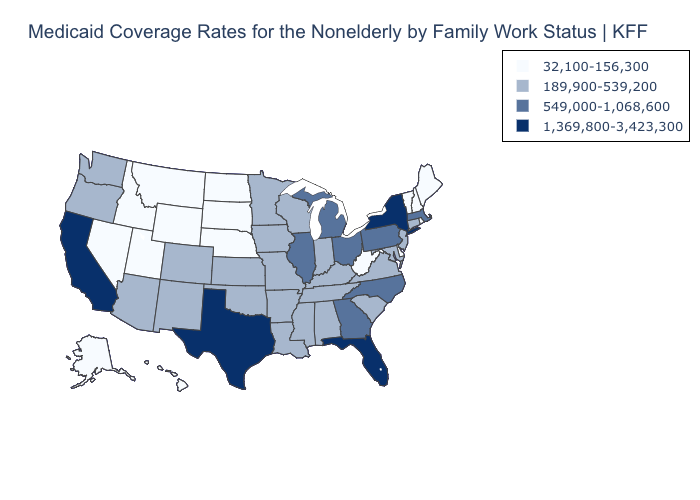What is the value of Wisconsin?
Concise answer only. 189,900-539,200. What is the value of Wyoming?
Answer briefly. 32,100-156,300. What is the highest value in states that border New York?
Quick response, please. 549,000-1,068,600. What is the highest value in the MidWest ?
Be succinct. 549,000-1,068,600. Does Florida have the highest value in the South?
Quick response, please. Yes. Does the map have missing data?
Concise answer only. No. What is the lowest value in states that border Massachusetts?
Concise answer only. 32,100-156,300. Does Washington have the highest value in the USA?
Short answer required. No. What is the lowest value in states that border Iowa?
Write a very short answer. 32,100-156,300. What is the highest value in the USA?
Concise answer only. 1,369,800-3,423,300. Does the first symbol in the legend represent the smallest category?
Be succinct. Yes. Among the states that border New Jersey , which have the highest value?
Keep it brief. New York. Does the map have missing data?
Answer briefly. No. What is the highest value in the Northeast ?
Give a very brief answer. 1,369,800-3,423,300. What is the highest value in the USA?
Write a very short answer. 1,369,800-3,423,300. 